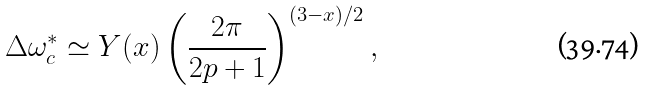Convert formula to latex. <formula><loc_0><loc_0><loc_500><loc_500>\Delta \omega _ { c } ^ { * } \simeq Y ( x ) \left ( \frac { 2 \pi } { 2 p + 1 } \right ) ^ { ( 3 - x ) / 2 } ,</formula> 